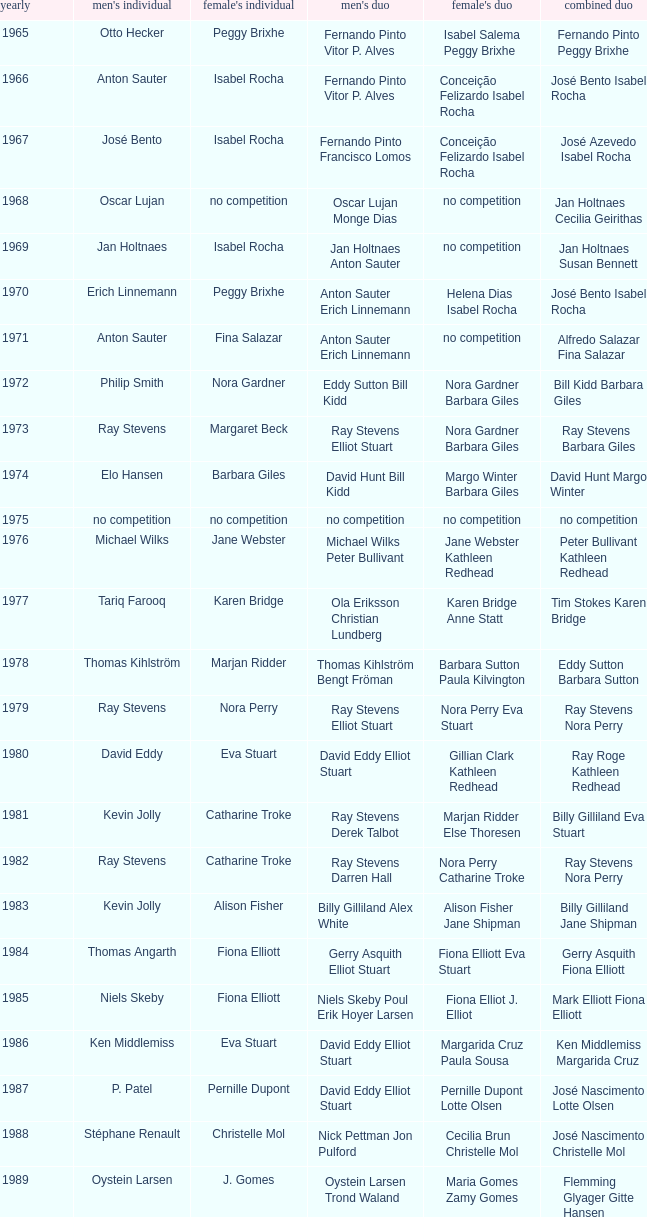Which women's doubles happened after 1987 and a women's single of astrid van der knaap? Elena Denisova Marina Yakusheva. 